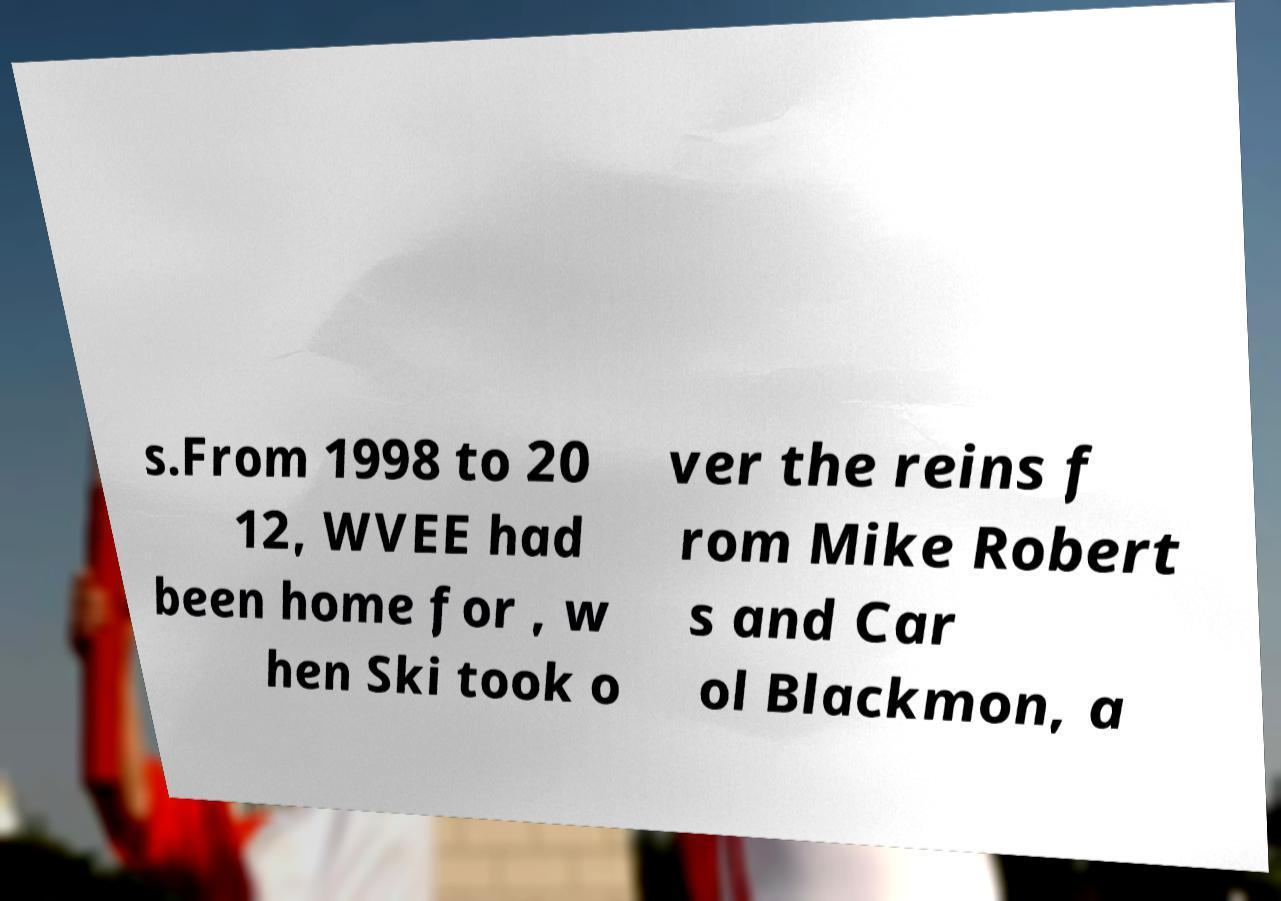What messages or text are displayed in this image? I need them in a readable, typed format. s.From 1998 to 20 12, WVEE had been home for , w hen Ski took o ver the reins f rom Mike Robert s and Car ol Blackmon, a 